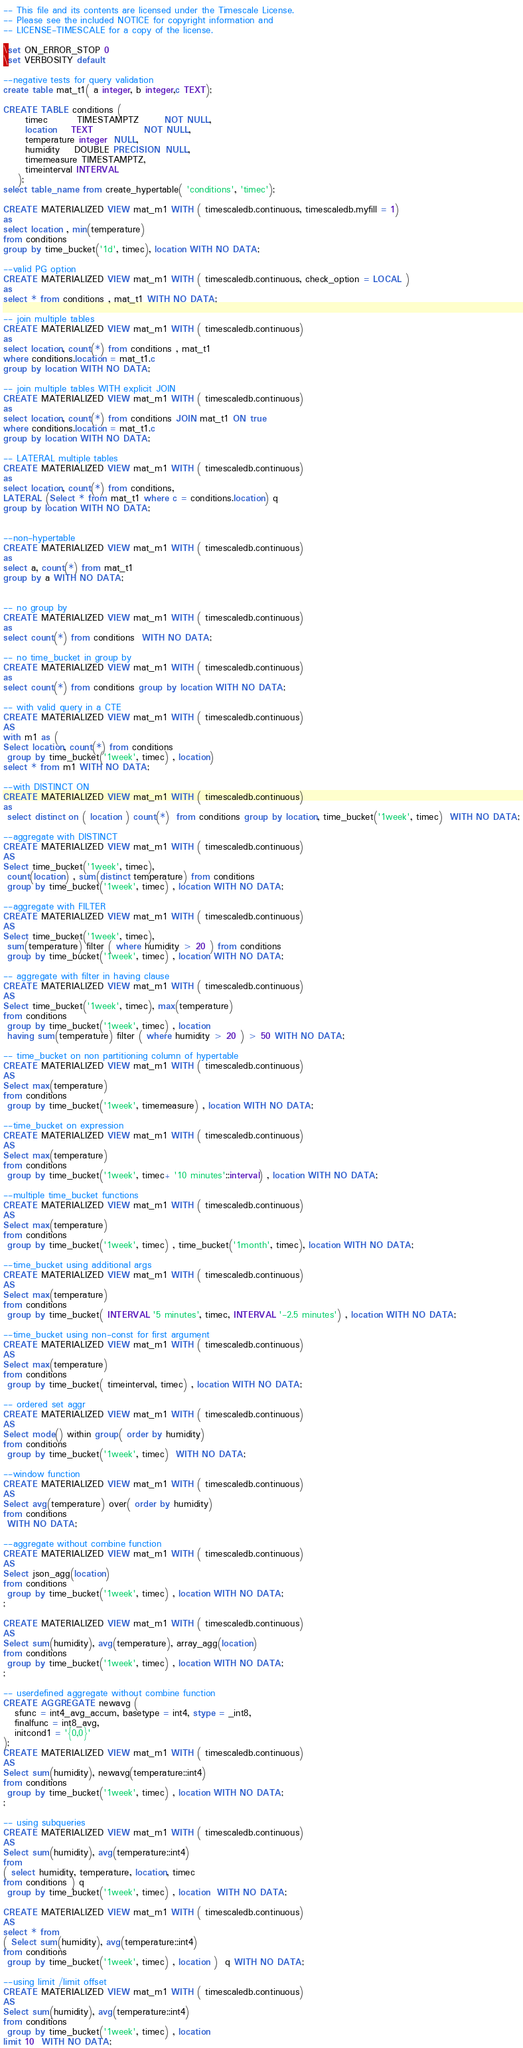<code> <loc_0><loc_0><loc_500><loc_500><_SQL_>-- This file and its contents are licensed under the Timescale License.
-- Please see the included NOTICE for copyright information and
-- LICENSE-TIMESCALE for a copy of the license.

\set ON_ERROR_STOP 0
\set VERBOSITY default

--negative tests for query validation
create table mat_t1( a integer, b integer,c TEXT);

CREATE TABLE conditions (
      timec        TIMESTAMPTZ       NOT NULL,
      location    TEXT              NOT NULL,
      temperature integer  NULL,
      humidity    DOUBLE PRECISION  NULL,
      timemeasure TIMESTAMPTZ,
      timeinterval INTERVAL
    );
select table_name from create_hypertable( 'conditions', 'timec');

CREATE MATERIALIZED VIEW mat_m1 WITH ( timescaledb.continuous, timescaledb.myfill = 1)
as
select location , min(temperature)
from conditions
group by time_bucket('1d', timec), location WITH NO DATA;

--valid PG option
CREATE MATERIALIZED VIEW mat_m1 WITH ( timescaledb.continuous, check_option = LOCAL )
as
select * from conditions , mat_t1 WITH NO DATA;

-- join multiple tables
CREATE MATERIALIZED VIEW mat_m1 WITH ( timescaledb.continuous)
as
select location, count(*) from conditions , mat_t1
where conditions.location = mat_t1.c
group by location WITH NO DATA;

-- join multiple tables WITH explicit JOIN
CREATE MATERIALIZED VIEW mat_m1 WITH ( timescaledb.continuous)
as
select location, count(*) from conditions JOIN mat_t1 ON true
where conditions.location = mat_t1.c
group by location WITH NO DATA;

-- LATERAL multiple tables
CREATE MATERIALIZED VIEW mat_m1 WITH ( timescaledb.continuous)
as
select location, count(*) from conditions,
LATERAL (Select * from mat_t1 where c = conditions.location) q
group by location WITH NO DATA;


--non-hypertable
CREATE MATERIALIZED VIEW mat_m1 WITH ( timescaledb.continuous)
as
select a, count(*) from mat_t1
group by a WITH NO DATA;


-- no group by
CREATE MATERIALIZED VIEW mat_m1 WITH ( timescaledb.continuous)
as
select count(*) from conditions  WITH NO DATA;

-- no time_bucket in group by
CREATE MATERIALIZED VIEW mat_m1 WITH ( timescaledb.continuous)
as
select count(*) from conditions group by location WITH NO DATA;

-- with valid query in a CTE
CREATE MATERIALIZED VIEW mat_m1 WITH ( timescaledb.continuous)
AS
with m1 as (
Select location, count(*) from conditions
 group by time_bucket('1week', timec) , location)
select * from m1 WITH NO DATA;

--with DISTINCT ON
CREATE MATERIALIZED VIEW mat_m1 WITH ( timescaledb.continuous)
as
 select distinct on ( location ) count(*)  from conditions group by location, time_bucket('1week', timec)  WITH NO DATA;

--aggregate with DISTINCT
CREATE MATERIALIZED VIEW mat_m1 WITH ( timescaledb.continuous)
AS
Select time_bucket('1week', timec),
 count(location) , sum(distinct temperature) from conditions
 group by time_bucket('1week', timec) , location WITH NO DATA;

--aggregate with FILTER
CREATE MATERIALIZED VIEW mat_m1 WITH ( timescaledb.continuous)
AS
Select time_bucket('1week', timec),
 sum(temperature) filter ( where humidity > 20 ) from conditions
 group by time_bucket('1week', timec) , location WITH NO DATA;

-- aggregate with filter in having clause
CREATE MATERIALIZED VIEW mat_m1 WITH ( timescaledb.continuous)
AS
Select time_bucket('1week', timec), max(temperature)
from conditions
 group by time_bucket('1week', timec) , location
 having sum(temperature) filter ( where humidity > 20 ) > 50 WITH NO DATA;

-- time_bucket on non partitioning column of hypertable
CREATE MATERIALIZED VIEW mat_m1 WITH ( timescaledb.continuous)
AS
Select max(temperature)
from conditions
 group by time_bucket('1week', timemeasure) , location WITH NO DATA;

--time_bucket on expression
CREATE MATERIALIZED VIEW mat_m1 WITH ( timescaledb.continuous)
AS
Select max(temperature)
from conditions
 group by time_bucket('1week', timec+ '10 minutes'::interval) , location WITH NO DATA;

--multiple time_bucket functions
CREATE MATERIALIZED VIEW mat_m1 WITH ( timescaledb.continuous)
AS
Select max(temperature)
from conditions
 group by time_bucket('1week', timec) , time_bucket('1month', timec), location WITH NO DATA;

--time_bucket using additional args
CREATE MATERIALIZED VIEW mat_m1 WITH ( timescaledb.continuous)
AS
Select max(temperature)
from conditions
 group by time_bucket( INTERVAL '5 minutes', timec, INTERVAL '-2.5 minutes') , location WITH NO DATA;

--time_bucket using non-const for first argument
CREATE MATERIALIZED VIEW mat_m1 WITH ( timescaledb.continuous)
AS
Select max(temperature)
from conditions
 group by time_bucket( timeinterval, timec) , location WITH NO DATA;

-- ordered set aggr
CREATE MATERIALIZED VIEW mat_m1 WITH ( timescaledb.continuous)
AS
Select mode() within group( order by humidity)
from conditions
 group by time_bucket('1week', timec)  WITH NO DATA;

--window function
CREATE MATERIALIZED VIEW mat_m1 WITH ( timescaledb.continuous)
AS
Select avg(temperature) over( order by humidity)
from conditions
 WITH NO DATA;

--aggregate without combine function
CREATE MATERIALIZED VIEW mat_m1 WITH ( timescaledb.continuous)
AS
Select json_agg(location)
from conditions
 group by time_bucket('1week', timec) , location WITH NO DATA;
;

CREATE MATERIALIZED VIEW mat_m1 WITH ( timescaledb.continuous)
AS
Select sum(humidity), avg(temperature), array_agg(location)
from conditions
 group by time_bucket('1week', timec) , location WITH NO DATA;
;

-- userdefined aggregate without combine function
CREATE AGGREGATE newavg (
   sfunc = int4_avg_accum, basetype = int4, stype = _int8,
   finalfunc = int8_avg,
   initcond1 = '{0,0}'
);
CREATE MATERIALIZED VIEW mat_m1 WITH ( timescaledb.continuous)
AS
Select sum(humidity), newavg(temperature::int4)
from conditions
 group by time_bucket('1week', timec) , location WITH NO DATA;
;

-- using subqueries
CREATE MATERIALIZED VIEW mat_m1 WITH ( timescaledb.continuous)
AS
Select sum(humidity), avg(temperature::int4)
from
( select humidity, temperature, location, timec
from conditions ) q
 group by time_bucket('1week', timec) , location  WITH NO DATA;

CREATE MATERIALIZED VIEW mat_m1 WITH ( timescaledb.continuous)
AS
select * from
( Select sum(humidity), avg(temperature::int4)
from conditions
 group by time_bucket('1week', timec) , location )  q WITH NO DATA;

--using limit /limit offset
CREATE MATERIALIZED VIEW mat_m1 WITH ( timescaledb.continuous)
AS
Select sum(humidity), avg(temperature::int4)
from conditions
 group by time_bucket('1week', timec) , location
limit 10  WITH NO DATA;
</code> 